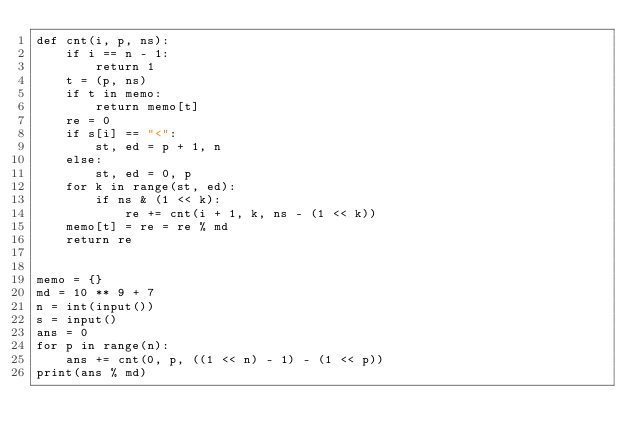<code> <loc_0><loc_0><loc_500><loc_500><_Python_>def cnt(i, p, ns):
    if i == n - 1:
        return 1
    t = (p, ns)
    if t in memo:
        return memo[t]
    re = 0
    if s[i] == "<":
        st, ed = p + 1, n
    else:
        st, ed = 0, p
    for k in range(st, ed):
        if ns & (1 << k):
            re += cnt(i + 1, k, ns - (1 << k))
    memo[t] = re = re % md
    return re


memo = {}
md = 10 ** 9 + 7
n = int(input())
s = input()
ans = 0
for p in range(n):
    ans += cnt(0, p, ((1 << n) - 1) - (1 << p))
print(ans % md)
</code> 